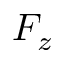Convert formula to latex. <formula><loc_0><loc_0><loc_500><loc_500>F _ { z }</formula> 